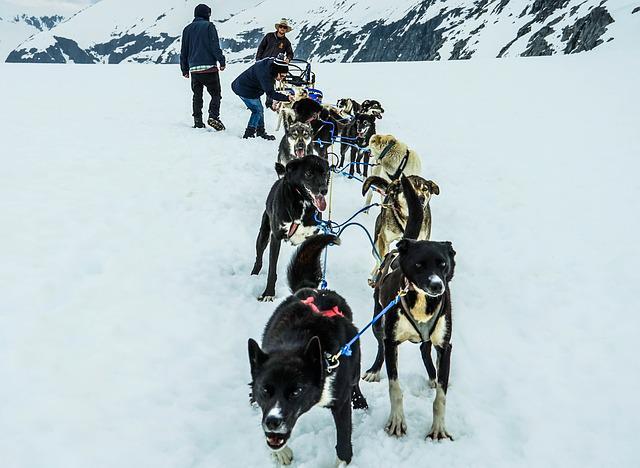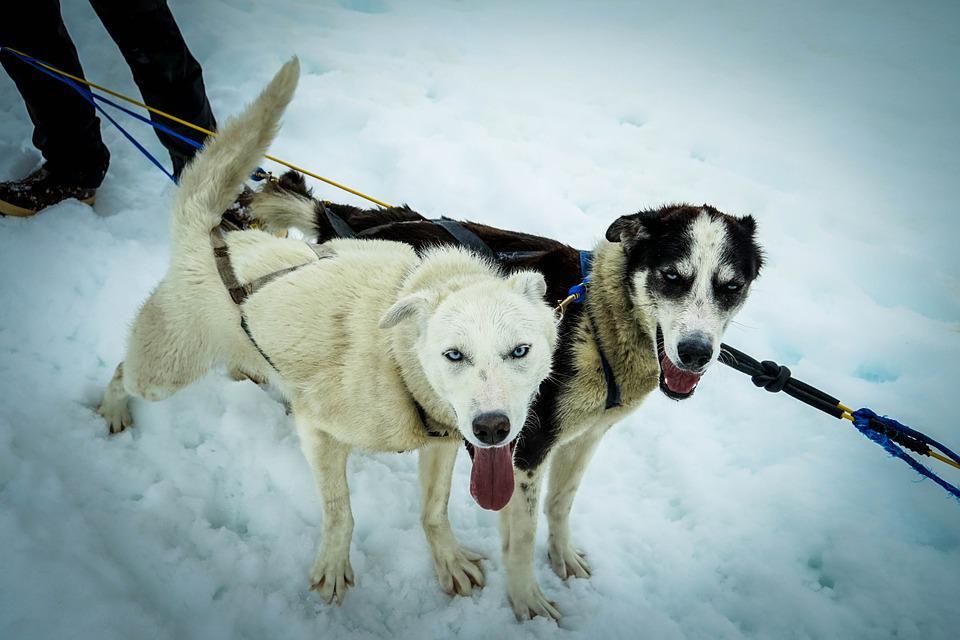The first image is the image on the left, the second image is the image on the right. Analyze the images presented: Is the assertion "There is a person wearing red outerwear." valid? Answer yes or no. No. The first image is the image on the left, the second image is the image on the right. Considering the images on both sides, is "One image does not show a rider with a sled." valid? Answer yes or no. Yes. 